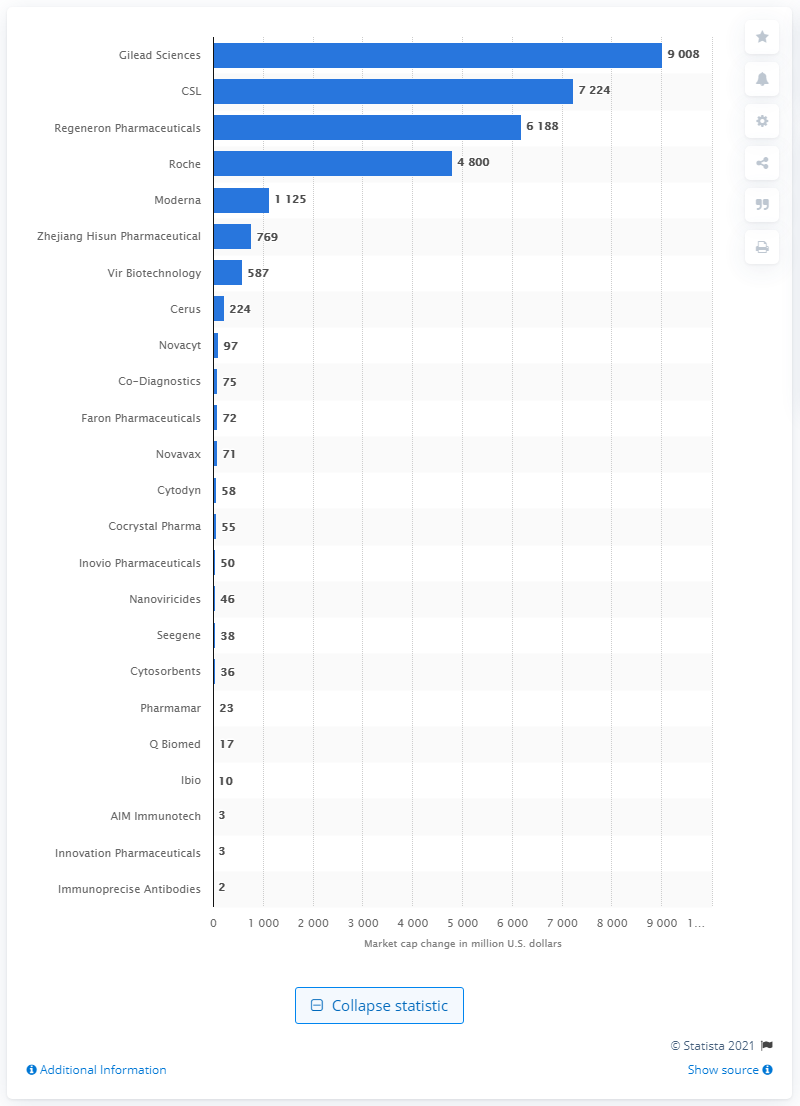Point out several critical features in this image. Gilead Sciences was the biopharmaceutical company that experienced the highest market capitalization change. 